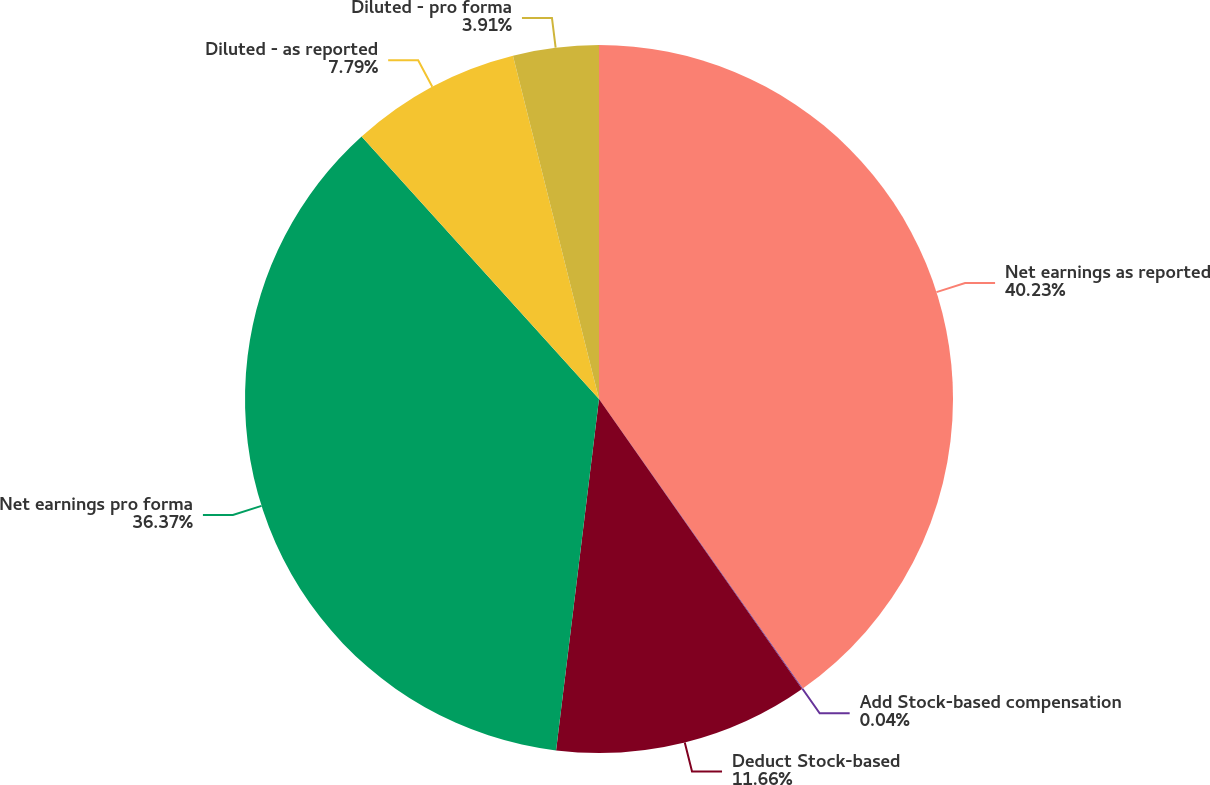Convert chart. <chart><loc_0><loc_0><loc_500><loc_500><pie_chart><fcel>Net earnings as reported<fcel>Add Stock-based compensation<fcel>Deduct Stock-based<fcel>Net earnings pro forma<fcel>Diluted - as reported<fcel>Diluted - pro forma<nl><fcel>40.24%<fcel>0.04%<fcel>11.66%<fcel>36.37%<fcel>7.79%<fcel>3.91%<nl></chart> 